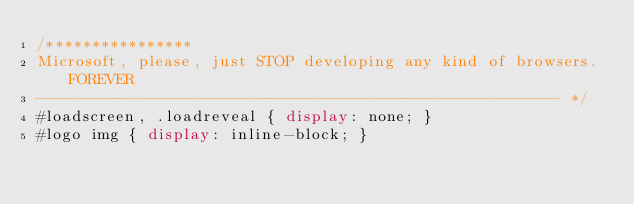Convert code to text. <code><loc_0><loc_0><loc_500><loc_500><_CSS_>/****************
Microsoft, please, just STOP developing any kind of browsers. FOREVER
--------------------------------------------------------- */
#loadscreen, .loadreveal { display: none; }
#logo img { display: inline-block; }</code> 